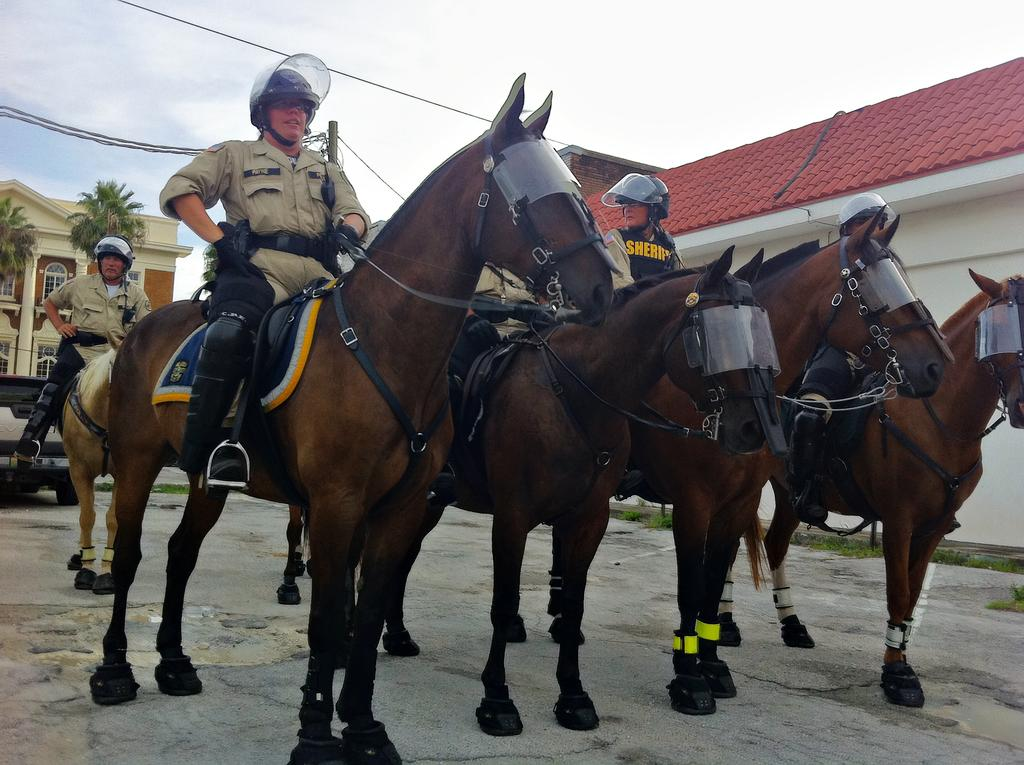What are the people in the image doing? The people in the image are riding horses. Where are the horses located in the image? The horses are in the middle of the image. What is behind the horses in the image? There is a vehicle behind the horses. What can be seen in the background of the image? There are buildings and trees in the background of the image. What is visible in the sky at the top of the image? There are clouds visible in the sky at the top of the image. What type of ornament is hanging from the chin of the horse in the image? There is no ornament hanging from the chin of the horse in the image; the horse is not wearing any ornament. 